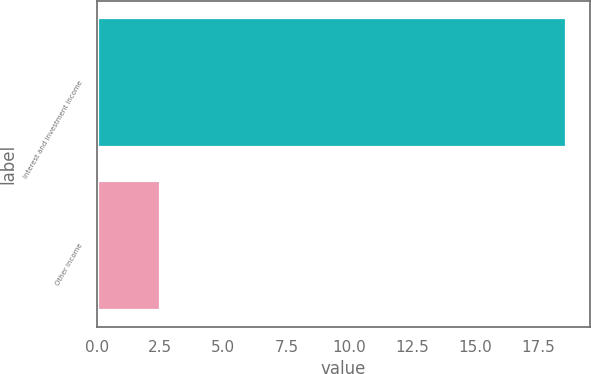<chart> <loc_0><loc_0><loc_500><loc_500><bar_chart><fcel>Interest and investment income<fcel>Other income<nl><fcel>18.6<fcel>2.5<nl></chart> 